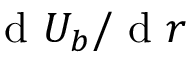Convert formula to latex. <formula><loc_0><loc_0><loc_500><loc_500>d U _ { b } / d r</formula> 